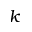Convert formula to latex. <formula><loc_0><loc_0><loc_500><loc_500>k</formula> 